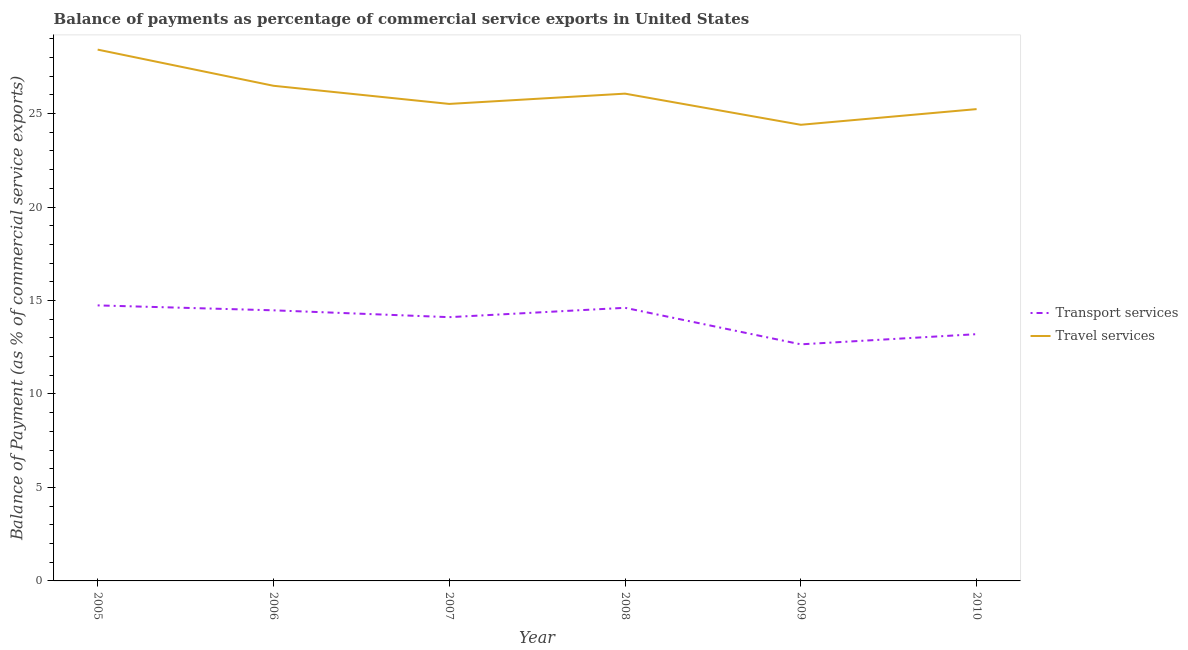What is the balance of payments of travel services in 2009?
Your answer should be very brief. 24.4. Across all years, what is the maximum balance of payments of travel services?
Provide a succinct answer. 28.42. Across all years, what is the minimum balance of payments of transport services?
Your answer should be very brief. 12.66. What is the total balance of payments of transport services in the graph?
Ensure brevity in your answer.  83.79. What is the difference between the balance of payments of travel services in 2008 and that in 2009?
Keep it short and to the point. 1.67. What is the difference between the balance of payments of transport services in 2007 and the balance of payments of travel services in 2006?
Your answer should be compact. -12.38. What is the average balance of payments of travel services per year?
Your answer should be very brief. 26.02. In the year 2008, what is the difference between the balance of payments of travel services and balance of payments of transport services?
Your response must be concise. 11.46. In how many years, is the balance of payments of transport services greater than 3 %?
Make the answer very short. 6. What is the ratio of the balance of payments of travel services in 2008 to that in 2009?
Provide a succinct answer. 1.07. Is the difference between the balance of payments of transport services in 2006 and 2008 greater than the difference between the balance of payments of travel services in 2006 and 2008?
Provide a succinct answer. No. What is the difference between the highest and the second highest balance of payments of travel services?
Offer a terse response. 1.93. What is the difference between the highest and the lowest balance of payments of transport services?
Offer a terse response. 2.08. In how many years, is the balance of payments of transport services greater than the average balance of payments of transport services taken over all years?
Offer a very short reply. 4. Is the balance of payments of travel services strictly greater than the balance of payments of transport services over the years?
Your answer should be very brief. Yes. How many lines are there?
Keep it short and to the point. 2. What is the difference between two consecutive major ticks on the Y-axis?
Offer a very short reply. 5. Are the values on the major ticks of Y-axis written in scientific E-notation?
Your response must be concise. No. Does the graph contain any zero values?
Give a very brief answer. No. How are the legend labels stacked?
Offer a terse response. Vertical. What is the title of the graph?
Your answer should be compact. Balance of payments as percentage of commercial service exports in United States. Does "Formally registered" appear as one of the legend labels in the graph?
Provide a short and direct response. No. What is the label or title of the Y-axis?
Make the answer very short. Balance of Payment (as % of commercial service exports). What is the Balance of Payment (as % of commercial service exports) in Transport services in 2005?
Your response must be concise. 14.74. What is the Balance of Payment (as % of commercial service exports) in Travel services in 2005?
Offer a terse response. 28.42. What is the Balance of Payment (as % of commercial service exports) in Transport services in 2006?
Ensure brevity in your answer.  14.48. What is the Balance of Payment (as % of commercial service exports) in Travel services in 2006?
Offer a terse response. 26.49. What is the Balance of Payment (as % of commercial service exports) in Transport services in 2007?
Make the answer very short. 14.11. What is the Balance of Payment (as % of commercial service exports) in Travel services in 2007?
Your answer should be very brief. 25.52. What is the Balance of Payment (as % of commercial service exports) in Transport services in 2008?
Ensure brevity in your answer.  14.61. What is the Balance of Payment (as % of commercial service exports) in Travel services in 2008?
Ensure brevity in your answer.  26.07. What is the Balance of Payment (as % of commercial service exports) of Transport services in 2009?
Your answer should be very brief. 12.66. What is the Balance of Payment (as % of commercial service exports) in Travel services in 2009?
Provide a short and direct response. 24.4. What is the Balance of Payment (as % of commercial service exports) of Transport services in 2010?
Offer a very short reply. 13.2. What is the Balance of Payment (as % of commercial service exports) of Travel services in 2010?
Ensure brevity in your answer.  25.24. Across all years, what is the maximum Balance of Payment (as % of commercial service exports) of Transport services?
Ensure brevity in your answer.  14.74. Across all years, what is the maximum Balance of Payment (as % of commercial service exports) in Travel services?
Provide a short and direct response. 28.42. Across all years, what is the minimum Balance of Payment (as % of commercial service exports) in Transport services?
Ensure brevity in your answer.  12.66. Across all years, what is the minimum Balance of Payment (as % of commercial service exports) in Travel services?
Keep it short and to the point. 24.4. What is the total Balance of Payment (as % of commercial service exports) of Transport services in the graph?
Offer a terse response. 83.79. What is the total Balance of Payment (as % of commercial service exports) in Travel services in the graph?
Keep it short and to the point. 156.13. What is the difference between the Balance of Payment (as % of commercial service exports) in Transport services in 2005 and that in 2006?
Offer a terse response. 0.26. What is the difference between the Balance of Payment (as % of commercial service exports) in Travel services in 2005 and that in 2006?
Your response must be concise. 1.93. What is the difference between the Balance of Payment (as % of commercial service exports) in Transport services in 2005 and that in 2007?
Your answer should be compact. 0.63. What is the difference between the Balance of Payment (as % of commercial service exports) in Travel services in 2005 and that in 2007?
Make the answer very short. 2.91. What is the difference between the Balance of Payment (as % of commercial service exports) in Transport services in 2005 and that in 2008?
Offer a terse response. 0.13. What is the difference between the Balance of Payment (as % of commercial service exports) in Travel services in 2005 and that in 2008?
Your response must be concise. 2.35. What is the difference between the Balance of Payment (as % of commercial service exports) of Transport services in 2005 and that in 2009?
Your answer should be very brief. 2.08. What is the difference between the Balance of Payment (as % of commercial service exports) in Travel services in 2005 and that in 2009?
Your answer should be compact. 4.02. What is the difference between the Balance of Payment (as % of commercial service exports) of Transport services in 2005 and that in 2010?
Your response must be concise. 1.54. What is the difference between the Balance of Payment (as % of commercial service exports) in Travel services in 2005 and that in 2010?
Give a very brief answer. 3.18. What is the difference between the Balance of Payment (as % of commercial service exports) of Transport services in 2006 and that in 2007?
Offer a terse response. 0.37. What is the difference between the Balance of Payment (as % of commercial service exports) of Travel services in 2006 and that in 2007?
Your response must be concise. 0.97. What is the difference between the Balance of Payment (as % of commercial service exports) in Transport services in 2006 and that in 2008?
Your response must be concise. -0.13. What is the difference between the Balance of Payment (as % of commercial service exports) in Travel services in 2006 and that in 2008?
Provide a short and direct response. 0.42. What is the difference between the Balance of Payment (as % of commercial service exports) in Transport services in 2006 and that in 2009?
Keep it short and to the point. 1.82. What is the difference between the Balance of Payment (as % of commercial service exports) in Travel services in 2006 and that in 2009?
Offer a very short reply. 2.09. What is the difference between the Balance of Payment (as % of commercial service exports) of Transport services in 2006 and that in 2010?
Offer a very short reply. 1.28. What is the difference between the Balance of Payment (as % of commercial service exports) in Travel services in 2006 and that in 2010?
Your answer should be very brief. 1.25. What is the difference between the Balance of Payment (as % of commercial service exports) of Transport services in 2007 and that in 2008?
Provide a succinct answer. -0.5. What is the difference between the Balance of Payment (as % of commercial service exports) in Travel services in 2007 and that in 2008?
Your answer should be very brief. -0.55. What is the difference between the Balance of Payment (as % of commercial service exports) in Transport services in 2007 and that in 2009?
Your response must be concise. 1.45. What is the difference between the Balance of Payment (as % of commercial service exports) of Travel services in 2007 and that in 2009?
Offer a terse response. 1.12. What is the difference between the Balance of Payment (as % of commercial service exports) of Transport services in 2007 and that in 2010?
Give a very brief answer. 0.91. What is the difference between the Balance of Payment (as % of commercial service exports) of Travel services in 2007 and that in 2010?
Your answer should be very brief. 0.28. What is the difference between the Balance of Payment (as % of commercial service exports) in Transport services in 2008 and that in 2009?
Give a very brief answer. 1.95. What is the difference between the Balance of Payment (as % of commercial service exports) in Transport services in 2008 and that in 2010?
Your answer should be very brief. 1.41. What is the difference between the Balance of Payment (as % of commercial service exports) in Travel services in 2008 and that in 2010?
Provide a succinct answer. 0.83. What is the difference between the Balance of Payment (as % of commercial service exports) in Transport services in 2009 and that in 2010?
Provide a short and direct response. -0.54. What is the difference between the Balance of Payment (as % of commercial service exports) of Travel services in 2009 and that in 2010?
Make the answer very short. -0.84. What is the difference between the Balance of Payment (as % of commercial service exports) of Transport services in 2005 and the Balance of Payment (as % of commercial service exports) of Travel services in 2006?
Provide a succinct answer. -11.75. What is the difference between the Balance of Payment (as % of commercial service exports) in Transport services in 2005 and the Balance of Payment (as % of commercial service exports) in Travel services in 2007?
Ensure brevity in your answer.  -10.78. What is the difference between the Balance of Payment (as % of commercial service exports) of Transport services in 2005 and the Balance of Payment (as % of commercial service exports) of Travel services in 2008?
Give a very brief answer. -11.33. What is the difference between the Balance of Payment (as % of commercial service exports) in Transport services in 2005 and the Balance of Payment (as % of commercial service exports) in Travel services in 2009?
Offer a terse response. -9.66. What is the difference between the Balance of Payment (as % of commercial service exports) of Transport services in 2005 and the Balance of Payment (as % of commercial service exports) of Travel services in 2010?
Your response must be concise. -10.5. What is the difference between the Balance of Payment (as % of commercial service exports) in Transport services in 2006 and the Balance of Payment (as % of commercial service exports) in Travel services in 2007?
Ensure brevity in your answer.  -11.04. What is the difference between the Balance of Payment (as % of commercial service exports) in Transport services in 2006 and the Balance of Payment (as % of commercial service exports) in Travel services in 2008?
Make the answer very short. -11.59. What is the difference between the Balance of Payment (as % of commercial service exports) of Transport services in 2006 and the Balance of Payment (as % of commercial service exports) of Travel services in 2009?
Provide a succinct answer. -9.92. What is the difference between the Balance of Payment (as % of commercial service exports) of Transport services in 2006 and the Balance of Payment (as % of commercial service exports) of Travel services in 2010?
Provide a succinct answer. -10.76. What is the difference between the Balance of Payment (as % of commercial service exports) in Transport services in 2007 and the Balance of Payment (as % of commercial service exports) in Travel services in 2008?
Give a very brief answer. -11.96. What is the difference between the Balance of Payment (as % of commercial service exports) in Transport services in 2007 and the Balance of Payment (as % of commercial service exports) in Travel services in 2009?
Provide a succinct answer. -10.29. What is the difference between the Balance of Payment (as % of commercial service exports) in Transport services in 2007 and the Balance of Payment (as % of commercial service exports) in Travel services in 2010?
Your response must be concise. -11.13. What is the difference between the Balance of Payment (as % of commercial service exports) of Transport services in 2008 and the Balance of Payment (as % of commercial service exports) of Travel services in 2009?
Ensure brevity in your answer.  -9.79. What is the difference between the Balance of Payment (as % of commercial service exports) in Transport services in 2008 and the Balance of Payment (as % of commercial service exports) in Travel services in 2010?
Keep it short and to the point. -10.63. What is the difference between the Balance of Payment (as % of commercial service exports) of Transport services in 2009 and the Balance of Payment (as % of commercial service exports) of Travel services in 2010?
Your response must be concise. -12.58. What is the average Balance of Payment (as % of commercial service exports) in Transport services per year?
Offer a terse response. 13.96. What is the average Balance of Payment (as % of commercial service exports) of Travel services per year?
Offer a very short reply. 26.02. In the year 2005, what is the difference between the Balance of Payment (as % of commercial service exports) of Transport services and Balance of Payment (as % of commercial service exports) of Travel services?
Offer a very short reply. -13.68. In the year 2006, what is the difference between the Balance of Payment (as % of commercial service exports) in Transport services and Balance of Payment (as % of commercial service exports) in Travel services?
Offer a very short reply. -12.01. In the year 2007, what is the difference between the Balance of Payment (as % of commercial service exports) in Transport services and Balance of Payment (as % of commercial service exports) in Travel services?
Give a very brief answer. -11.41. In the year 2008, what is the difference between the Balance of Payment (as % of commercial service exports) in Transport services and Balance of Payment (as % of commercial service exports) in Travel services?
Offer a very short reply. -11.46. In the year 2009, what is the difference between the Balance of Payment (as % of commercial service exports) of Transport services and Balance of Payment (as % of commercial service exports) of Travel services?
Make the answer very short. -11.74. In the year 2010, what is the difference between the Balance of Payment (as % of commercial service exports) in Transport services and Balance of Payment (as % of commercial service exports) in Travel services?
Provide a succinct answer. -12.04. What is the ratio of the Balance of Payment (as % of commercial service exports) in Transport services in 2005 to that in 2006?
Your answer should be very brief. 1.02. What is the ratio of the Balance of Payment (as % of commercial service exports) in Travel services in 2005 to that in 2006?
Your answer should be compact. 1.07. What is the ratio of the Balance of Payment (as % of commercial service exports) in Transport services in 2005 to that in 2007?
Your answer should be very brief. 1.04. What is the ratio of the Balance of Payment (as % of commercial service exports) of Travel services in 2005 to that in 2007?
Make the answer very short. 1.11. What is the ratio of the Balance of Payment (as % of commercial service exports) of Transport services in 2005 to that in 2008?
Offer a terse response. 1.01. What is the ratio of the Balance of Payment (as % of commercial service exports) in Travel services in 2005 to that in 2008?
Provide a short and direct response. 1.09. What is the ratio of the Balance of Payment (as % of commercial service exports) of Transport services in 2005 to that in 2009?
Offer a terse response. 1.16. What is the ratio of the Balance of Payment (as % of commercial service exports) in Travel services in 2005 to that in 2009?
Offer a very short reply. 1.16. What is the ratio of the Balance of Payment (as % of commercial service exports) in Transport services in 2005 to that in 2010?
Give a very brief answer. 1.12. What is the ratio of the Balance of Payment (as % of commercial service exports) in Travel services in 2005 to that in 2010?
Provide a succinct answer. 1.13. What is the ratio of the Balance of Payment (as % of commercial service exports) in Transport services in 2006 to that in 2007?
Keep it short and to the point. 1.03. What is the ratio of the Balance of Payment (as % of commercial service exports) in Travel services in 2006 to that in 2007?
Keep it short and to the point. 1.04. What is the ratio of the Balance of Payment (as % of commercial service exports) of Travel services in 2006 to that in 2008?
Offer a terse response. 1.02. What is the ratio of the Balance of Payment (as % of commercial service exports) of Transport services in 2006 to that in 2009?
Make the answer very short. 1.14. What is the ratio of the Balance of Payment (as % of commercial service exports) in Travel services in 2006 to that in 2009?
Ensure brevity in your answer.  1.09. What is the ratio of the Balance of Payment (as % of commercial service exports) in Transport services in 2006 to that in 2010?
Your answer should be compact. 1.1. What is the ratio of the Balance of Payment (as % of commercial service exports) of Travel services in 2006 to that in 2010?
Ensure brevity in your answer.  1.05. What is the ratio of the Balance of Payment (as % of commercial service exports) of Transport services in 2007 to that in 2008?
Provide a succinct answer. 0.97. What is the ratio of the Balance of Payment (as % of commercial service exports) of Travel services in 2007 to that in 2008?
Offer a terse response. 0.98. What is the ratio of the Balance of Payment (as % of commercial service exports) in Transport services in 2007 to that in 2009?
Ensure brevity in your answer.  1.11. What is the ratio of the Balance of Payment (as % of commercial service exports) of Travel services in 2007 to that in 2009?
Ensure brevity in your answer.  1.05. What is the ratio of the Balance of Payment (as % of commercial service exports) of Transport services in 2007 to that in 2010?
Provide a short and direct response. 1.07. What is the ratio of the Balance of Payment (as % of commercial service exports) in Travel services in 2007 to that in 2010?
Your answer should be very brief. 1.01. What is the ratio of the Balance of Payment (as % of commercial service exports) in Transport services in 2008 to that in 2009?
Your answer should be very brief. 1.15. What is the ratio of the Balance of Payment (as % of commercial service exports) in Travel services in 2008 to that in 2009?
Make the answer very short. 1.07. What is the ratio of the Balance of Payment (as % of commercial service exports) in Transport services in 2008 to that in 2010?
Your answer should be compact. 1.11. What is the ratio of the Balance of Payment (as % of commercial service exports) in Travel services in 2008 to that in 2010?
Give a very brief answer. 1.03. What is the ratio of the Balance of Payment (as % of commercial service exports) of Transport services in 2009 to that in 2010?
Offer a very short reply. 0.96. What is the ratio of the Balance of Payment (as % of commercial service exports) in Travel services in 2009 to that in 2010?
Your response must be concise. 0.97. What is the difference between the highest and the second highest Balance of Payment (as % of commercial service exports) in Transport services?
Your response must be concise. 0.13. What is the difference between the highest and the second highest Balance of Payment (as % of commercial service exports) in Travel services?
Your response must be concise. 1.93. What is the difference between the highest and the lowest Balance of Payment (as % of commercial service exports) in Transport services?
Offer a very short reply. 2.08. What is the difference between the highest and the lowest Balance of Payment (as % of commercial service exports) of Travel services?
Offer a terse response. 4.02. 